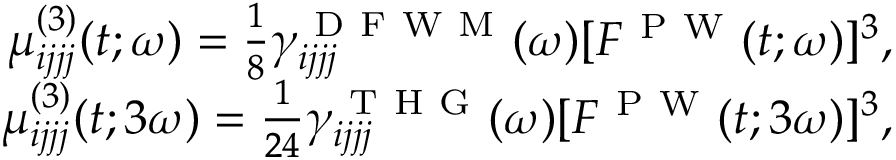Convert formula to latex. <formula><loc_0><loc_0><loc_500><loc_500>\begin{array} { r } { \mu _ { i j j j } ^ { ( 3 ) } ( t ; \omega ) = \frac { 1 } { 8 } \gamma _ { i j j j } ^ { D F W M } ( \omega ) [ F ^ { P W } ( t ; \omega ) ] ^ { 3 } , } \\ { \mu _ { i j j j } ^ { ( 3 ) } ( t ; 3 \omega ) = \frac { 1 } { 2 4 } \gamma _ { i j j j } ^ { T H G } ( \omega ) [ F ^ { P W } ( t ; 3 \omega ) ] ^ { 3 } , } \end{array}</formula> 